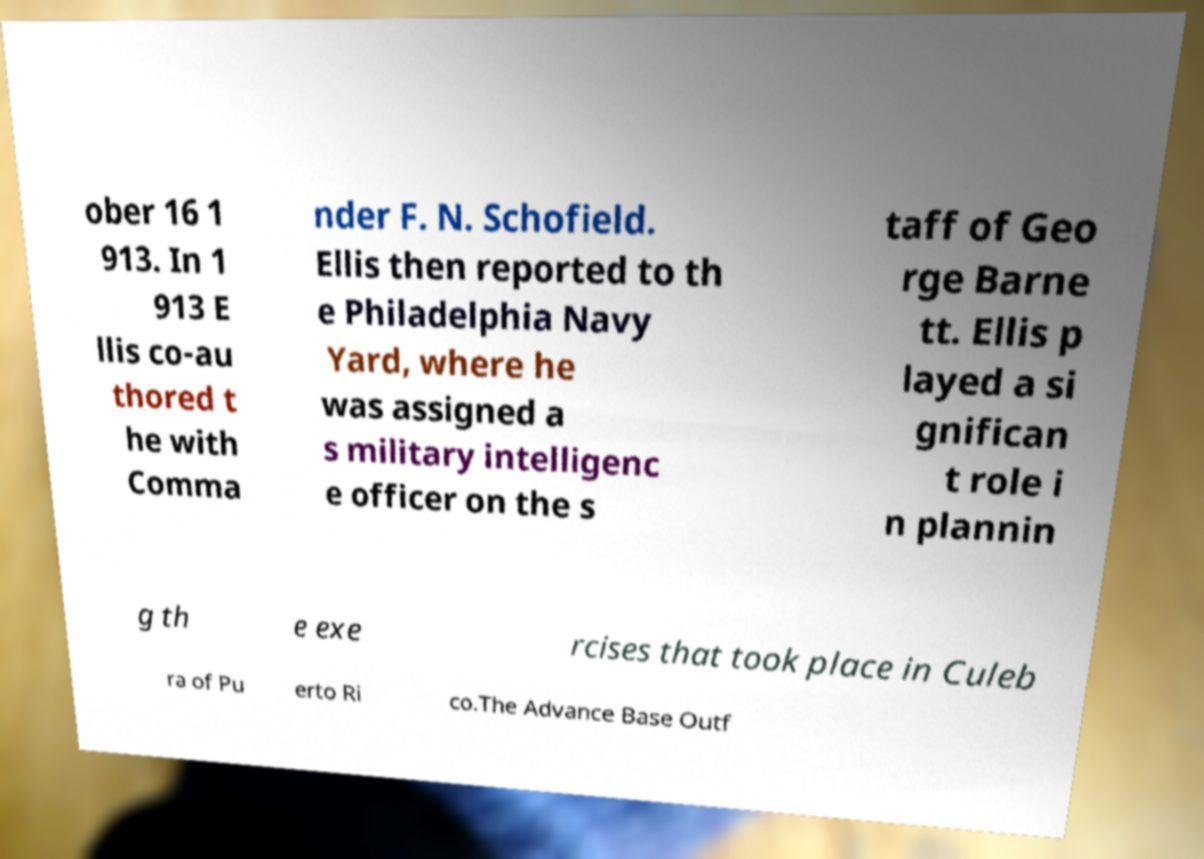What messages or text are displayed in this image? I need them in a readable, typed format. ober 16 1 913. In 1 913 E llis co-au thored t he with Comma nder F. N. Schofield. Ellis then reported to th e Philadelphia Navy Yard, where he was assigned a s military intelligenc e officer on the s taff of Geo rge Barne tt. Ellis p layed a si gnifican t role i n plannin g th e exe rcises that took place in Culeb ra of Pu erto Ri co.The Advance Base Outf 